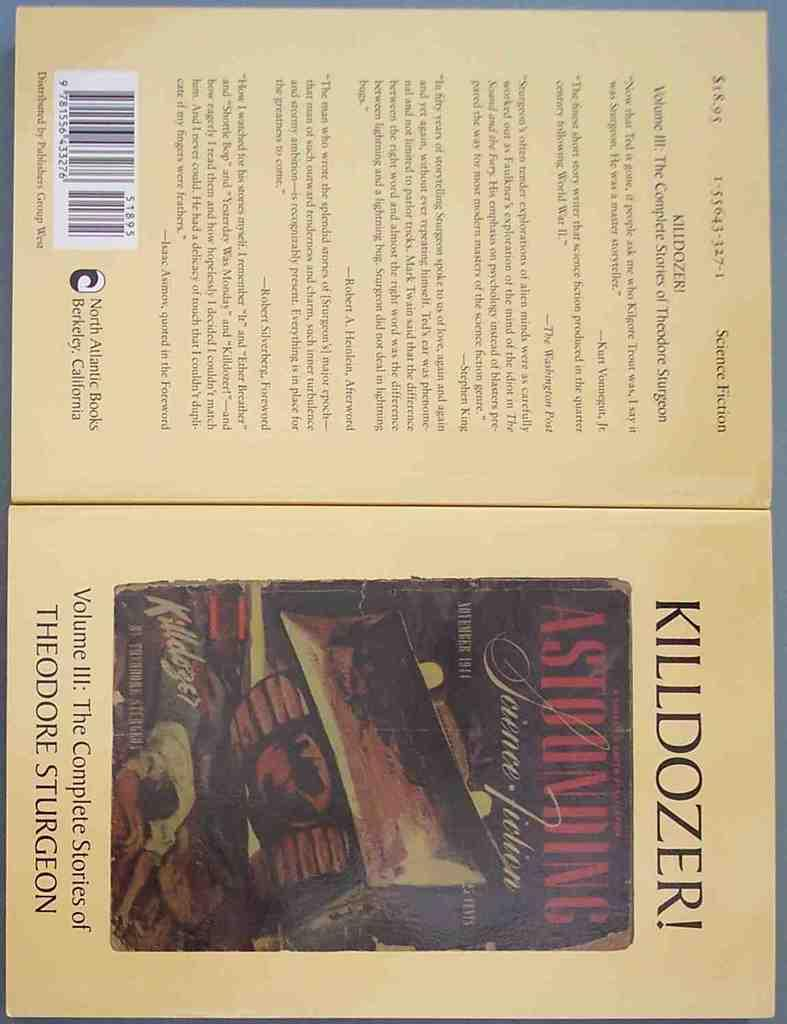<image>
Summarize the visual content of the image. The front and back of a book by the author Theodore Sturgeon 